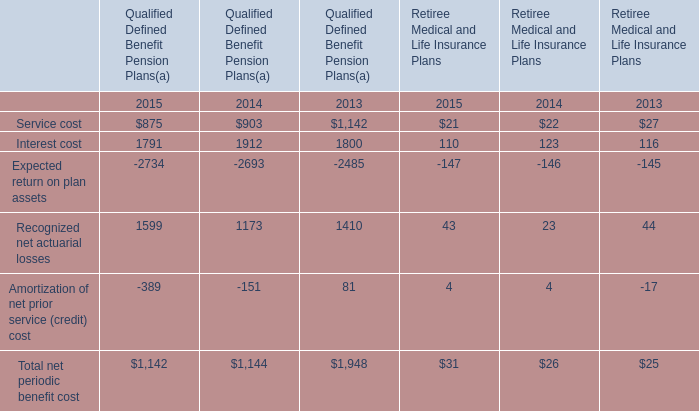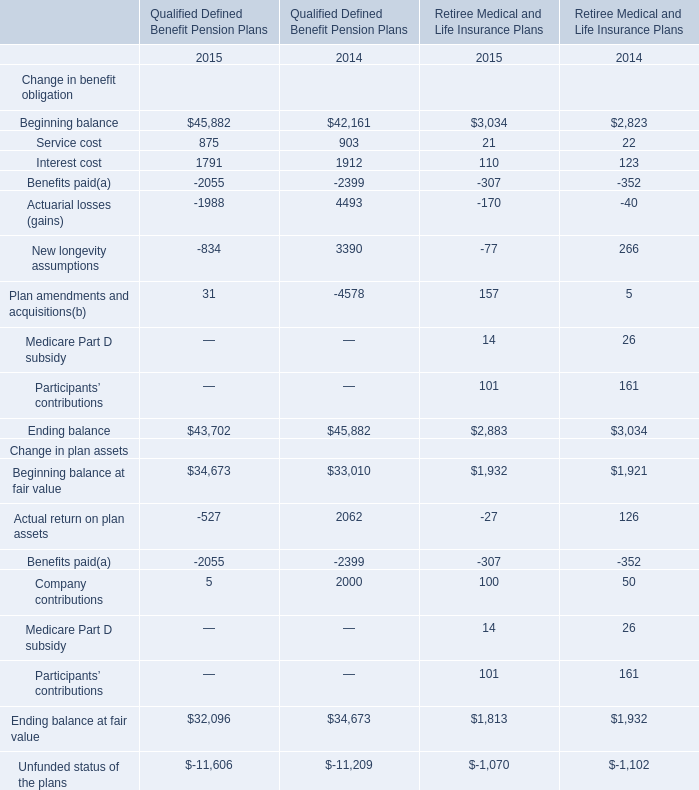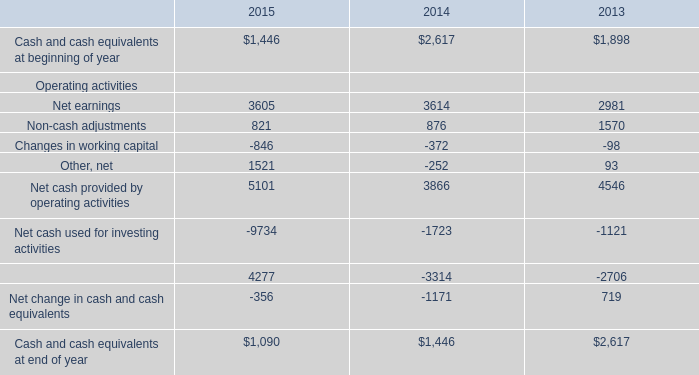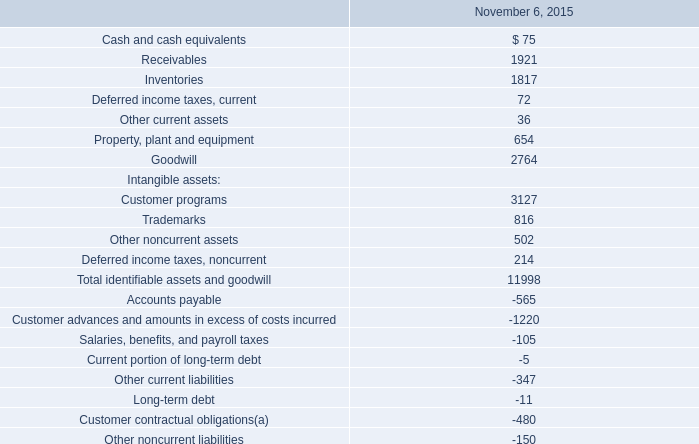What do all elements for Qualified Defined Benefit Pension Plans sum up, excluding those negative ones in 2015? 
Computations: ((875 + 1791) + 1599)
Answer: 4265.0. 